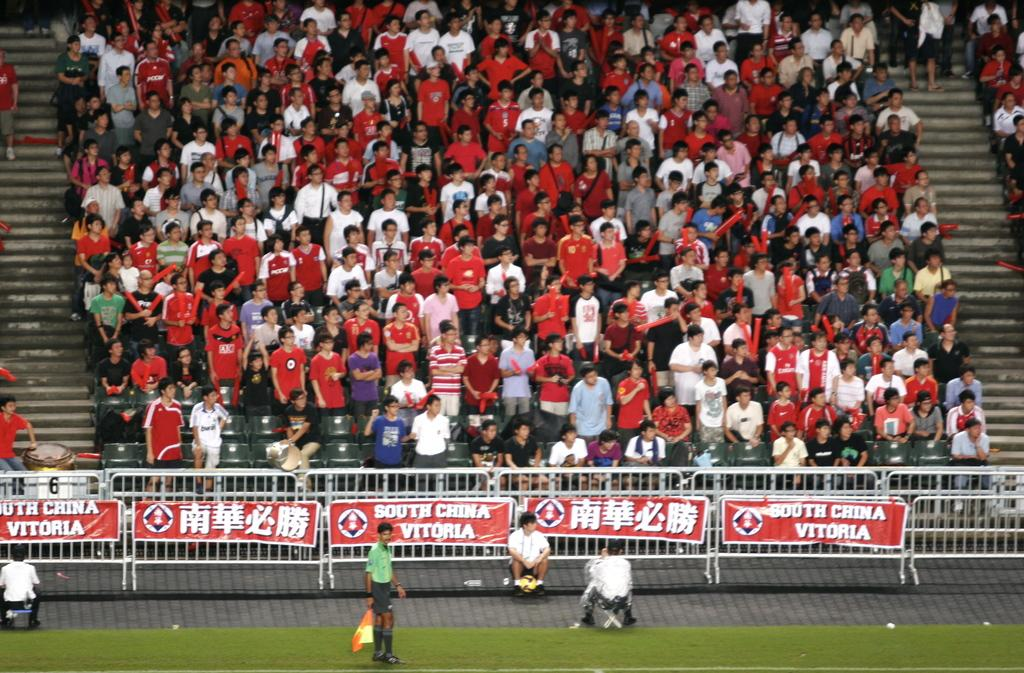<image>
Render a clear and concise summary of the photo. A banner on the lower right side reads "South China Vitoria." 